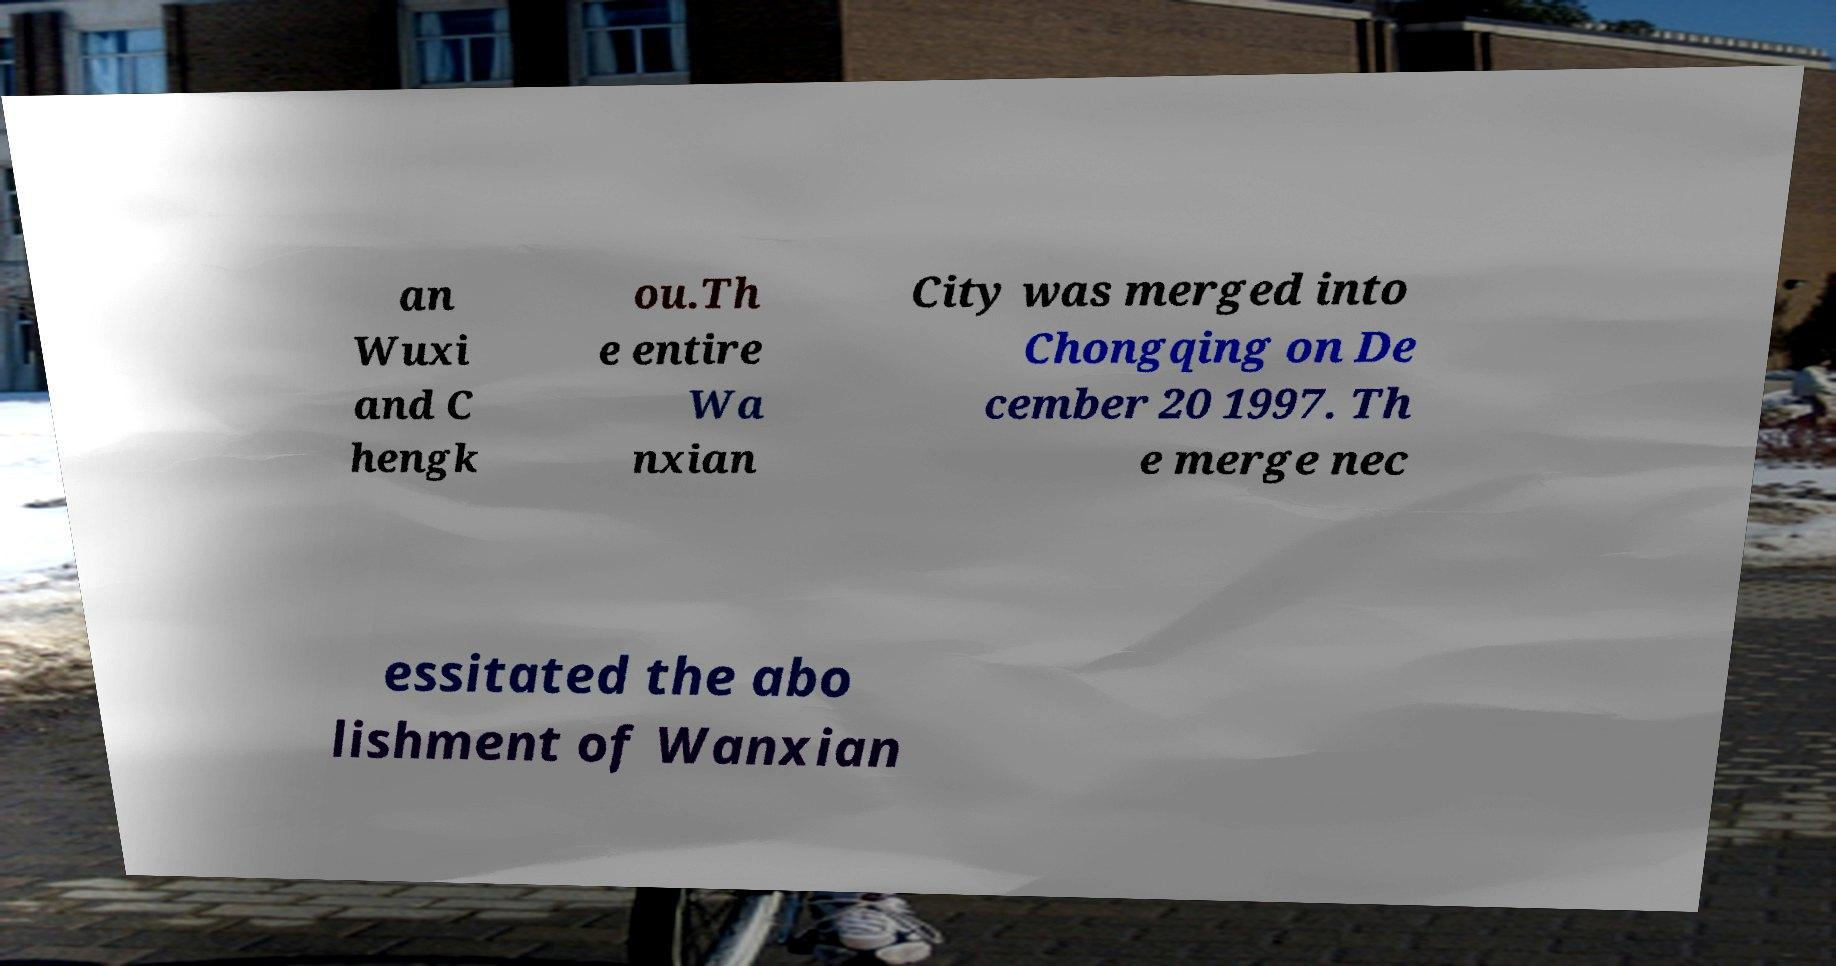For documentation purposes, I need the text within this image transcribed. Could you provide that? an Wuxi and C hengk ou.Th e entire Wa nxian City was merged into Chongqing on De cember 20 1997. Th e merge nec essitated the abo lishment of Wanxian 